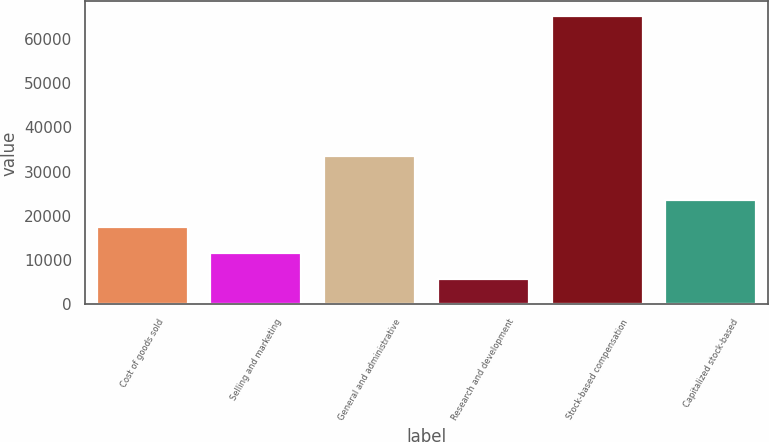Convert chart. <chart><loc_0><loc_0><loc_500><loc_500><bar_chart><fcel>Cost of goods sold<fcel>Selling and marketing<fcel>General and administrative<fcel>Research and development<fcel>Stock-based compensation<fcel>Capitalized stock-based<nl><fcel>17602<fcel>11646.5<fcel>33636<fcel>5691<fcel>65246<fcel>23557.5<nl></chart> 